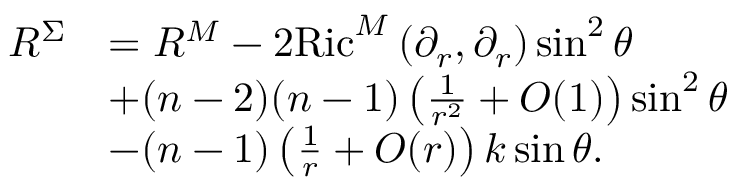<formula> <loc_0><loc_0><loc_500><loc_500>\begin{array} { r l } { R ^ { \Sigma } } & { = R ^ { M } - 2 R i c ^ { M } \left ( \partial _ { r } , \partial _ { r } \right ) \sin ^ { 2 } \theta } \\ & { + ( n - 2 ) ( n - 1 ) \left ( \frac { 1 } { r ^ { 2 } } + O ( 1 ) \right ) \sin ^ { 2 } \theta } \\ & { - ( n - 1 ) \left ( \frac { 1 } { r } + O ( r ) \right ) k \sin \theta . } \end{array}</formula> 